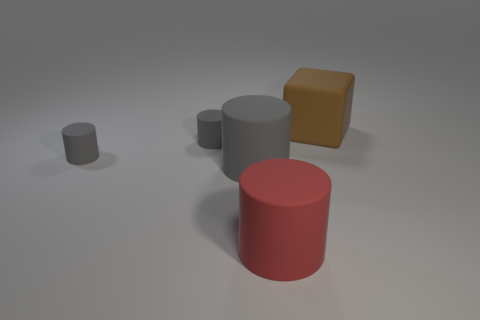There is a big gray object that is the same shape as the large red matte object; what is its material?
Make the answer very short. Rubber. What is the color of the large rubber cube?
Offer a very short reply. Brown. There is a big matte thing that is on the right side of the big red cylinder; what number of large things are left of it?
Offer a terse response. 2. What is the size of the thing that is on the right side of the big gray matte object and in front of the large brown matte cube?
Offer a very short reply. Large. There is a brown object to the right of the large red rubber thing; what is it made of?
Offer a very short reply. Rubber. Is there a red thing that has the same shape as the large gray object?
Provide a short and direct response. Yes. What number of other big things have the same shape as the big red matte object?
Offer a terse response. 1. There is a rubber block that is behind the red cylinder; does it have the same size as the cylinder to the right of the big gray rubber object?
Provide a succinct answer. Yes. There is a rubber object in front of the big object that is to the left of the red object; what is its shape?
Your answer should be very brief. Cylinder. Is the number of large brown matte things that are on the right side of the block the same as the number of big gray rubber balls?
Keep it short and to the point. Yes. 